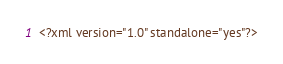<code> <loc_0><loc_0><loc_500><loc_500><_XML_><?xml version="1.0" standalone="yes"?>
</code> 